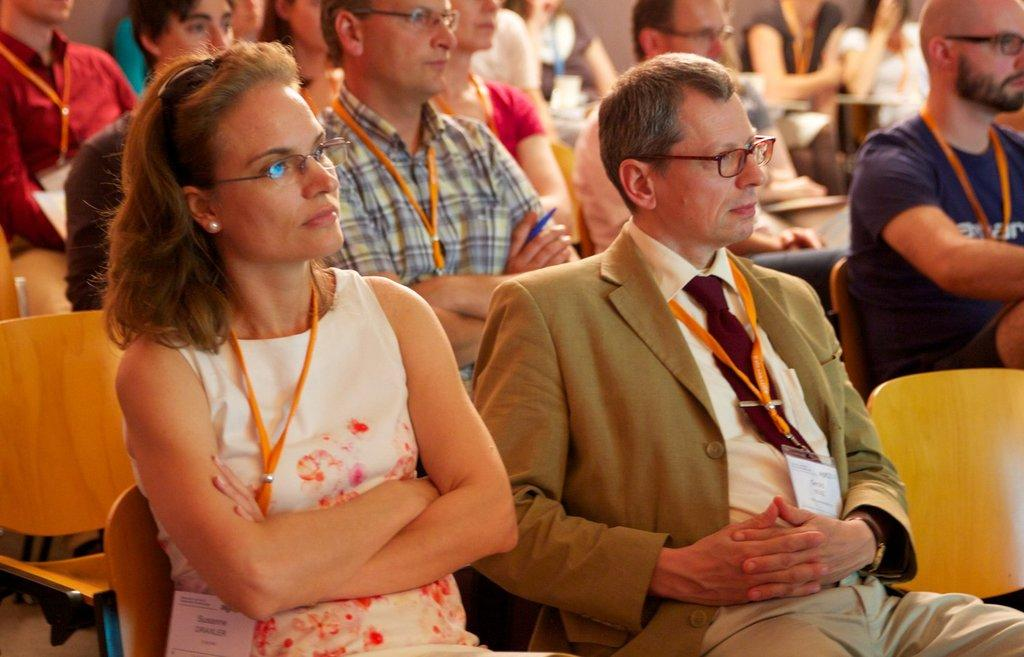What are the people in the image doing? The people in the image are sitting on chairs. What can be seen hanging around their necks? The people have ID cards hanging around their necks. What are the people wearing on their faces? The people are wearing spectacles. In which direction are the people looking? The people are looking towards the right side of the image. What type of wine is being served in the image? There is no wine present in the image; it features people sitting on chairs with ID cards and spectacles. 